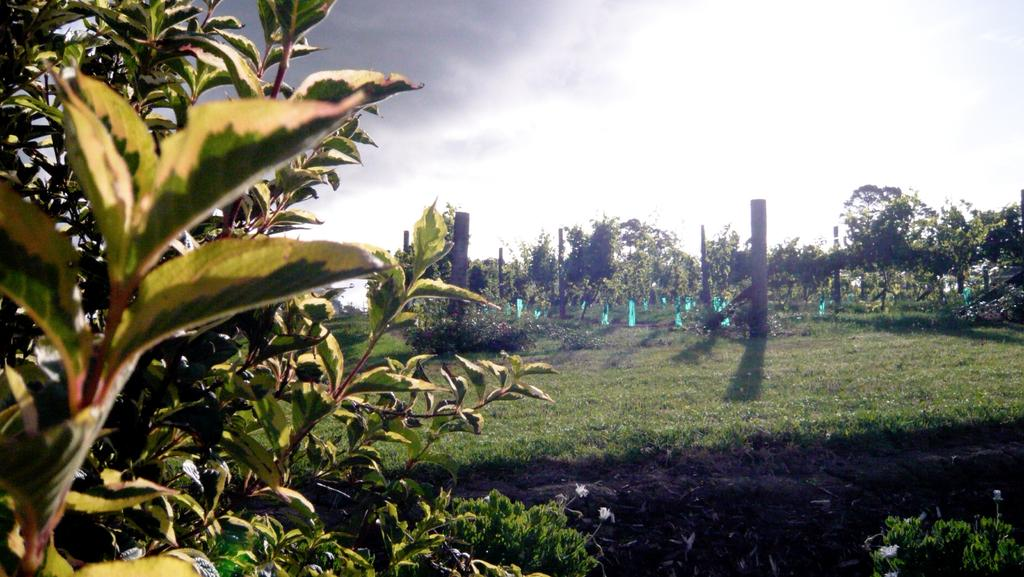What color are the flowers on the plants in the image? The flowers on the plants are white. What can be seen in the background of the image? There are many trees, poles, clouds, and the sky visible in the background. Can you describe the vegetation in the image? The image features plants with white flowers and trees in the background. How many horses are visible in the image? There are no horses present in the image. What position do the clouds hold in the image? The clouds are in the background of the image, but they do not hold a specific position. 